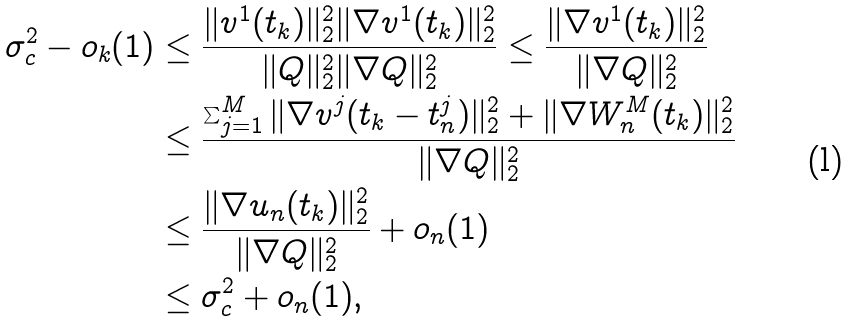Convert formula to latex. <formula><loc_0><loc_0><loc_500><loc_500>\sigma _ { c } ^ { 2 } - o _ { k } ( 1 ) & \leq \frac { \| v ^ { 1 } ( t _ { k } ) \| ^ { 2 } _ { 2 } \| \nabla v ^ { 1 } ( t _ { k } ) \| ^ { 2 } _ { 2 } } { \| Q \| ^ { 2 } _ { 2 } \| \nabla Q \| ^ { 2 } _ { 2 } } \leq \frac { \| \nabla v ^ { 1 } ( t _ { k } ) \| ^ { 2 } _ { 2 } } { \| \nabla Q \| ^ { 2 } _ { 2 } } \\ & \leq \frac { \sum _ { j = 1 } ^ { M } \| \nabla v ^ { j } ( t _ { k } - t _ { n } ^ { j } ) \| ^ { 2 } _ { 2 } + \| \nabla W _ { n } ^ { M } ( t _ { k } ) \| ^ { 2 } _ { 2 } } { \| \nabla Q \| ^ { 2 } _ { 2 } } \\ & \leq \frac { \| \nabla u _ { n } ( t _ { k } ) \| ^ { 2 } _ { 2 } } { \| \nabla Q \| ^ { 2 } _ { 2 } } + o _ { n } ( 1 ) \\ & \leq \sigma _ { c } ^ { 2 } + o _ { n } ( 1 ) ,</formula> 